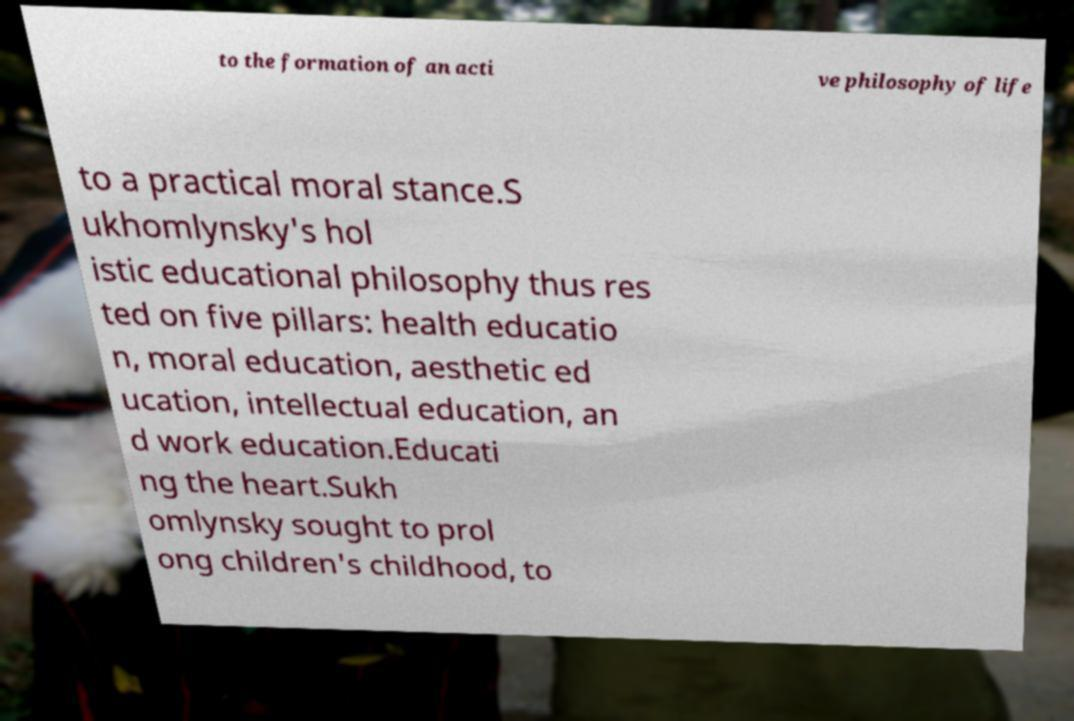I need the written content from this picture converted into text. Can you do that? to the formation of an acti ve philosophy of life to a practical moral stance.S ukhomlynsky's hol istic educational philosophy thus res ted on five pillars: health educatio n, moral education, aesthetic ed ucation, intellectual education, an d work education.Educati ng the heart.Sukh omlynsky sought to prol ong children's childhood, to 